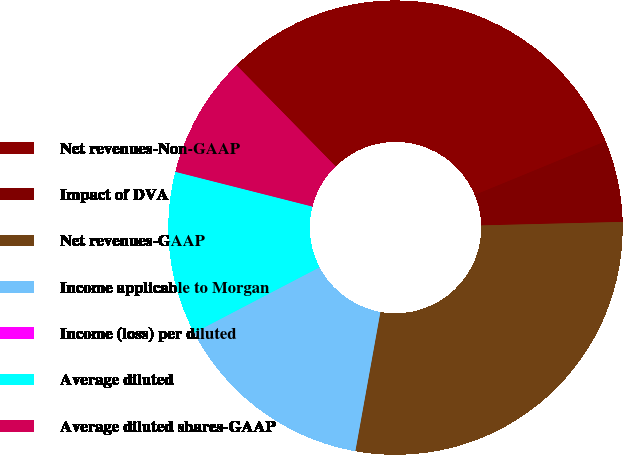<chart> <loc_0><loc_0><loc_500><loc_500><pie_chart><fcel>Net revenues-Non-GAAP<fcel>Impact of DVA<fcel>Net revenues-GAAP<fcel>Income applicable to Morgan<fcel>Income (loss) per diluted<fcel>Average diluted<fcel>Average diluted shares-GAAP<nl><fcel>31.13%<fcel>5.81%<fcel>28.23%<fcel>14.51%<fcel>0.0%<fcel>11.61%<fcel>8.71%<nl></chart> 